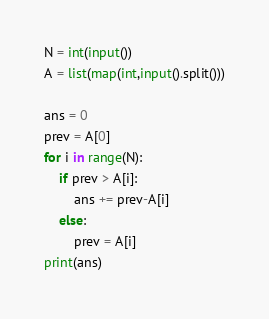<code> <loc_0><loc_0><loc_500><loc_500><_Python_>N = int(input())
A = list(map(int,input().split()))

ans = 0
prev = A[0]
for i in range(N):
    if prev > A[i]:
        ans += prev-A[i]
    else:
        prev = A[i]
print(ans)
</code> 